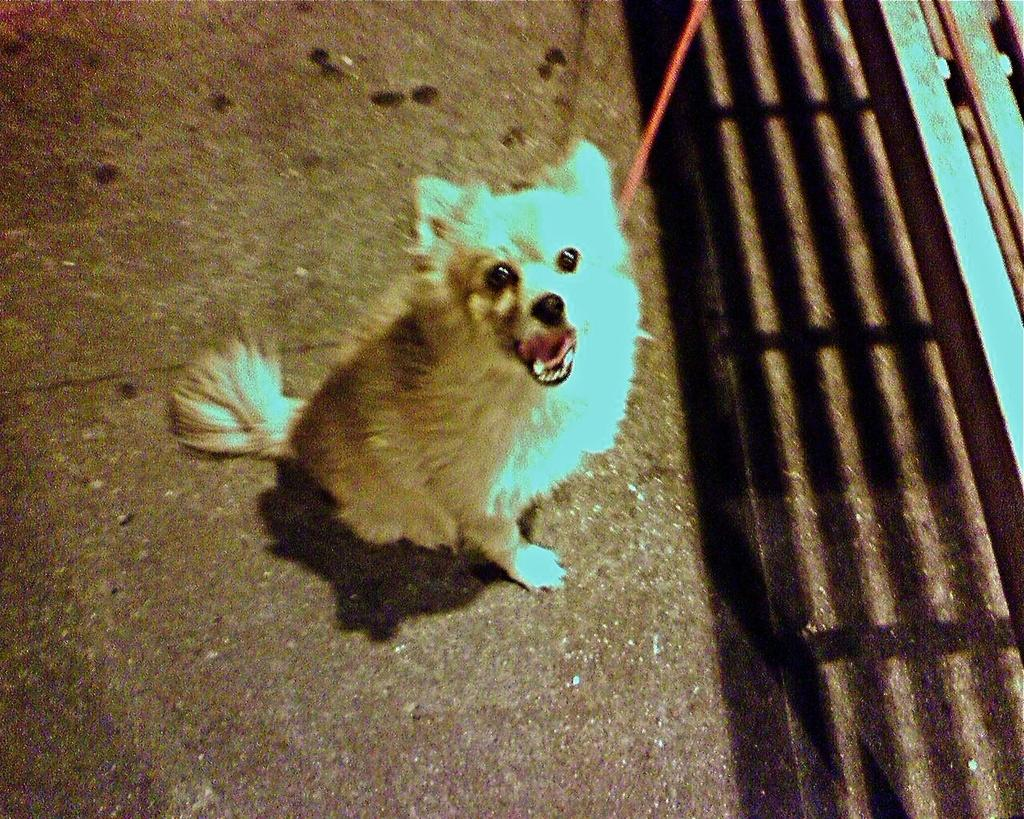What type of animal is in the image? There is a dog in the image. Where is the dog located? The dog is on a road. What other object can be seen on the right side of the image? There is a bench on the right side of the image. What type of monkey is sitting on the bench in the image? There is no monkey present in the image; it features a dog on a road and a bench on the right side. 